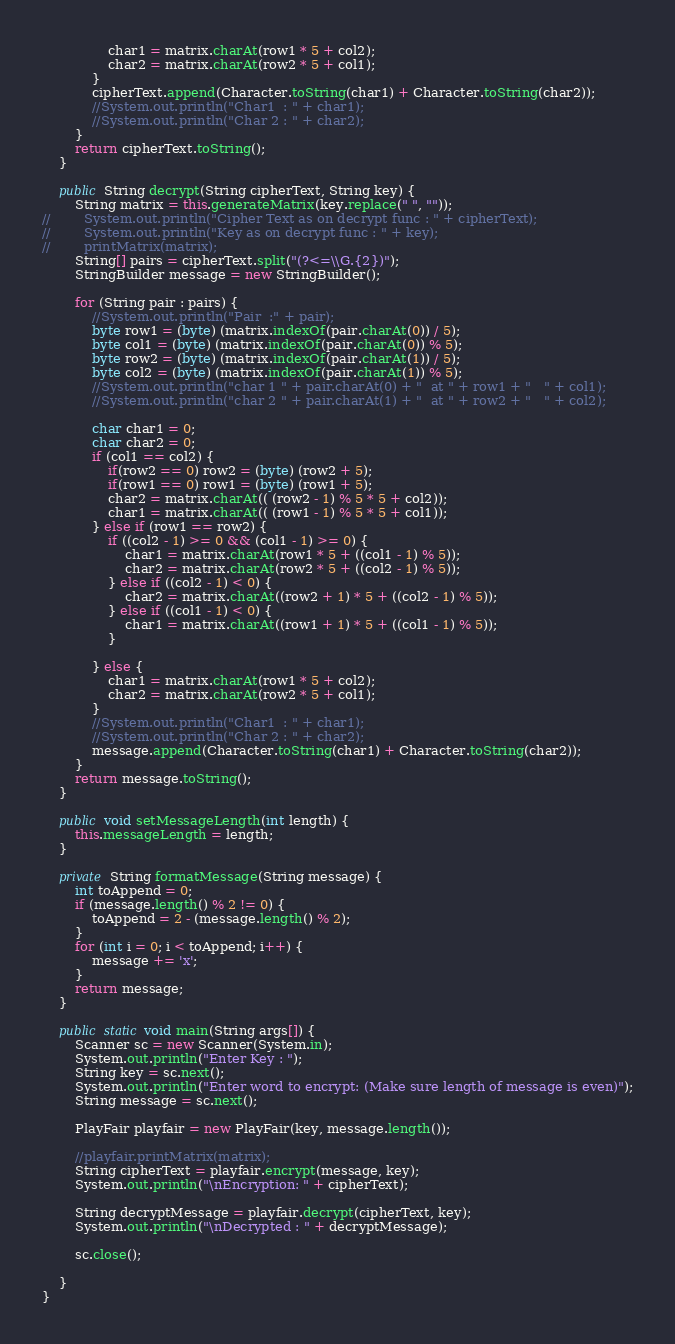Convert code to text. <code><loc_0><loc_0><loc_500><loc_500><_Java_>                char1 = matrix.charAt(row1 * 5 + col2);
                char2 = matrix.charAt(row2 * 5 + col1);
            }
            cipherText.append(Character.toString(char1) + Character.toString(char2));
            //System.out.println("Char1  : " + char1);
            //System.out.println("Char 2 : " + char2);
        }
        return cipherText.toString();
    }

    public String decrypt(String cipherText, String key) {
        String matrix = this.generateMatrix(key.replace(" ", ""));
//        System.out.println("Cipher Text as on decrypt func : " + cipherText);
//        System.out.println("Key as on decrypt func : " + key);
//        printMatrix(matrix);
        String[] pairs = cipherText.split("(?<=\\G.{2})");
        StringBuilder message = new StringBuilder();

        for (String pair : pairs) {
            //System.out.println("Pair  :" + pair);
            byte row1 = (byte) (matrix.indexOf(pair.charAt(0)) / 5);
            byte col1 = (byte) (matrix.indexOf(pair.charAt(0)) % 5);
            byte row2 = (byte) (matrix.indexOf(pair.charAt(1)) / 5);
            byte col2 = (byte) (matrix.indexOf(pair.charAt(1)) % 5);
            //System.out.println("char 1 " + pair.charAt(0) + "  at " + row1 + "   " + col1);
            //System.out.println("char 2 " + pair.charAt(1) + "  at " + row2 + "   " + col2);

            char char1 = 0;
            char char2 = 0;
            if (col1 == col2) {
                if(row2 == 0) row2 = (byte) (row2 + 5);
                if(row1 == 0) row1 = (byte) (row1 + 5);
                char2 = matrix.charAt(( (row2 - 1) % 5 * 5 + col2));
                char1 = matrix.charAt(( (row1 - 1) % 5 * 5 + col1));
            } else if (row1 == row2) {
                if ((col2 - 1) >= 0 && (col1 - 1) >= 0) {
                    char1 = matrix.charAt(row1 * 5 + ((col1 - 1) % 5));
                    char2 = matrix.charAt(row2 * 5 + ((col2 - 1) % 5));
                } else if ((col2 - 1) < 0) {
                    char2 = matrix.charAt((row2 + 1) * 5 + ((col2 - 1) % 5));
                } else if ((col1 - 1) < 0) {
                    char1 = matrix.charAt((row1 + 1) * 5 + ((col1 - 1) % 5));
                }

            } else {
                char1 = matrix.charAt(row1 * 5 + col2);
                char2 = matrix.charAt(row2 * 5 + col1);
            }
            //System.out.println("Char1  : " + char1);
            //System.out.println("Char 2 : " + char2);
            message.append(Character.toString(char1) + Character.toString(char2));
        }
        return message.toString();
    }

    public void setMessageLength(int length) {
        this.messageLength = length;
    }

    private String formatMessage(String message) {
        int toAppend = 0;
        if (message.length() % 2 != 0) {
            toAppend = 2 - (message.length() % 2);
        }
        for (int i = 0; i < toAppend; i++) {
            message += 'x';
        }
        return message;
    }

    public static void main(String args[]) {
        Scanner sc = new Scanner(System.in);
        System.out.println("Enter Key : ");
        String key = sc.next();
        System.out.println("Enter word to encrypt: (Make sure length of message is even)");
        String message = sc.next();

        PlayFair playfair = new PlayFair(key, message.length());

        //playfair.printMatrix(matrix);
        String cipherText = playfair.encrypt(message, key);
        System.out.println("\nEncryption: " + cipherText);

        String decryptMessage = playfair.decrypt(cipherText, key);
        System.out.println("\nDecrypted : " + decryptMessage);

        sc.close();

    }
}
</code> 